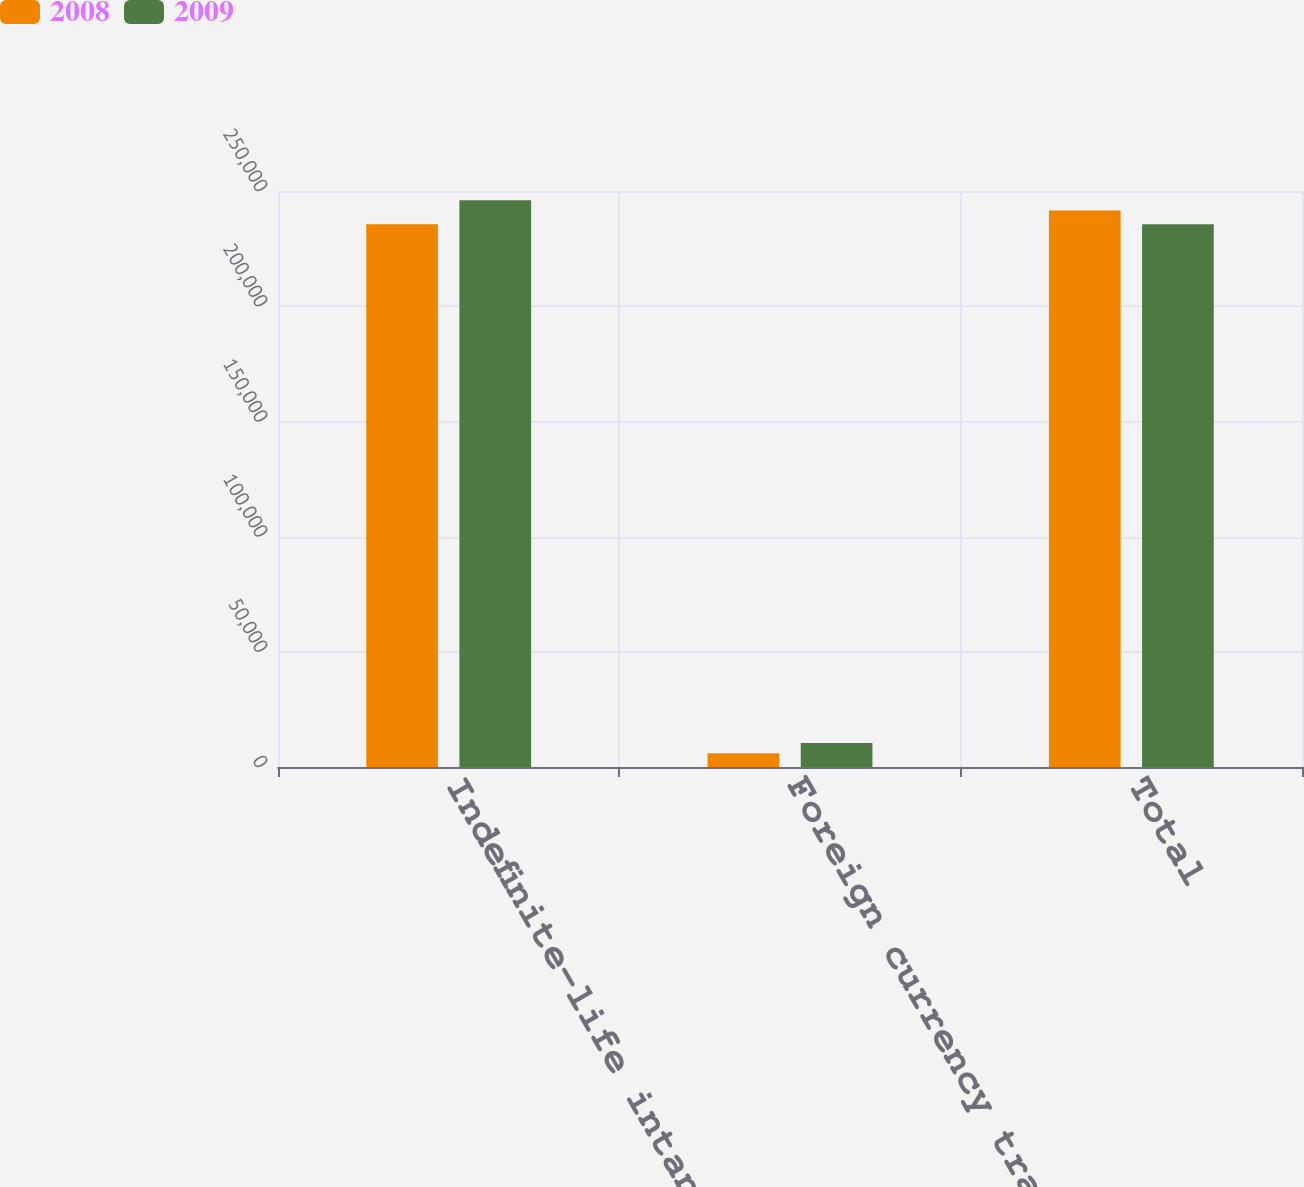Convert chart. <chart><loc_0><loc_0><loc_500><loc_500><stacked_bar_chart><ecel><fcel>Indefinite-life intangible<fcel>Foreign currency translation<fcel>Total<nl><fcel>2008<fcel>235610<fcel>5953<fcel>241563<nl><fcel>2009<fcel>246014<fcel>10404<fcel>235610<nl></chart> 